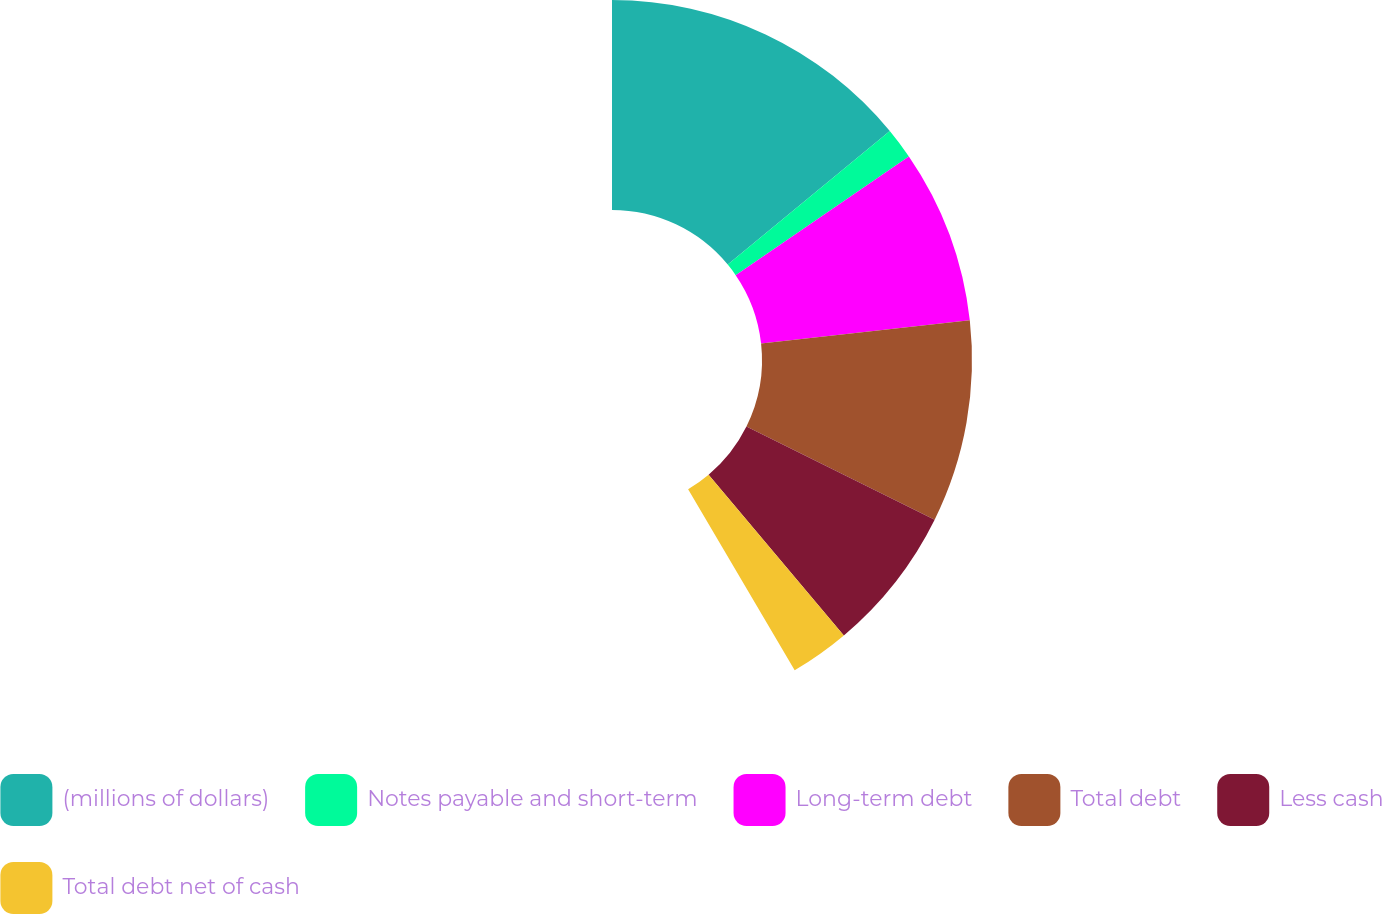<chart> <loc_0><loc_0><loc_500><loc_500><pie_chart><fcel>(millions of dollars)<fcel>Notes payable and short-term<fcel>Long-term debt<fcel>Total debt<fcel>Less cash<fcel>Total debt net of cash<nl><fcel>33.78%<fcel>3.38%<fcel>18.81%<fcel>21.84%<fcel>15.77%<fcel>6.42%<nl></chart> 